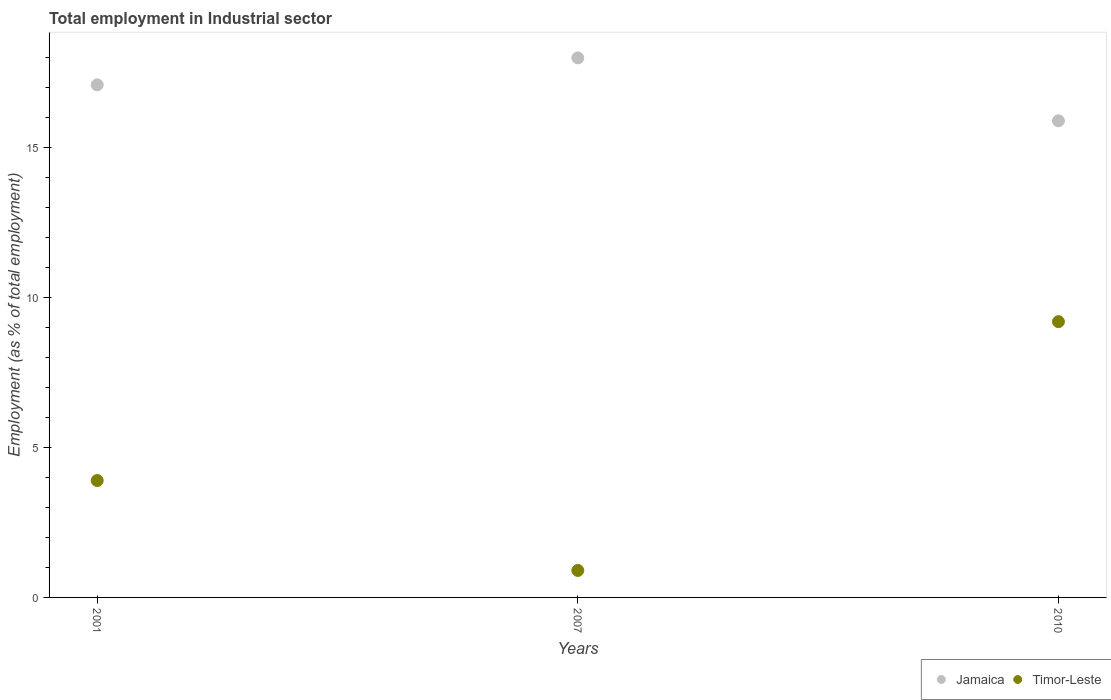What is the employment in industrial sector in Jamaica in 2001?
Your response must be concise. 17.1. Across all years, what is the maximum employment in industrial sector in Timor-Leste?
Give a very brief answer. 9.2. Across all years, what is the minimum employment in industrial sector in Jamaica?
Offer a very short reply. 15.9. In which year was the employment in industrial sector in Jamaica maximum?
Your answer should be compact. 2007. What is the total employment in industrial sector in Timor-Leste in the graph?
Ensure brevity in your answer.  14. What is the difference between the employment in industrial sector in Timor-Leste in 2007 and that in 2010?
Provide a short and direct response. -8.3. What is the difference between the employment in industrial sector in Jamaica in 2007 and the employment in industrial sector in Timor-Leste in 2010?
Offer a terse response. 8.8. In the year 2010, what is the difference between the employment in industrial sector in Jamaica and employment in industrial sector in Timor-Leste?
Give a very brief answer. 6.7. What is the ratio of the employment in industrial sector in Timor-Leste in 2007 to that in 2010?
Your answer should be very brief. 0.1. What is the difference between the highest and the second highest employment in industrial sector in Timor-Leste?
Offer a very short reply. 5.3. What is the difference between the highest and the lowest employment in industrial sector in Jamaica?
Give a very brief answer. 2.1. Does the employment in industrial sector in Timor-Leste monotonically increase over the years?
Ensure brevity in your answer.  No. Is the employment in industrial sector in Timor-Leste strictly less than the employment in industrial sector in Jamaica over the years?
Your response must be concise. Yes. How many years are there in the graph?
Your answer should be very brief. 3. Where does the legend appear in the graph?
Provide a short and direct response. Bottom right. How many legend labels are there?
Give a very brief answer. 2. How are the legend labels stacked?
Offer a very short reply. Horizontal. What is the title of the graph?
Offer a very short reply. Total employment in Industrial sector. Does "Bosnia and Herzegovina" appear as one of the legend labels in the graph?
Give a very brief answer. No. What is the label or title of the Y-axis?
Make the answer very short. Employment (as % of total employment). What is the Employment (as % of total employment) in Jamaica in 2001?
Provide a short and direct response. 17.1. What is the Employment (as % of total employment) in Timor-Leste in 2001?
Provide a succinct answer. 3.9. What is the Employment (as % of total employment) in Jamaica in 2007?
Provide a short and direct response. 18. What is the Employment (as % of total employment) of Timor-Leste in 2007?
Offer a terse response. 0.9. What is the Employment (as % of total employment) in Jamaica in 2010?
Provide a short and direct response. 15.9. What is the Employment (as % of total employment) of Timor-Leste in 2010?
Give a very brief answer. 9.2. Across all years, what is the maximum Employment (as % of total employment) in Timor-Leste?
Your answer should be very brief. 9.2. Across all years, what is the minimum Employment (as % of total employment) of Jamaica?
Your answer should be compact. 15.9. Across all years, what is the minimum Employment (as % of total employment) of Timor-Leste?
Ensure brevity in your answer.  0.9. What is the total Employment (as % of total employment) of Timor-Leste in the graph?
Give a very brief answer. 14. What is the difference between the Employment (as % of total employment) of Jamaica in 2001 and that in 2007?
Offer a terse response. -0.9. What is the difference between the Employment (as % of total employment) in Timor-Leste in 2001 and that in 2007?
Offer a terse response. 3. What is the difference between the Employment (as % of total employment) in Jamaica in 2001 and that in 2010?
Make the answer very short. 1.2. What is the difference between the Employment (as % of total employment) in Timor-Leste in 2001 and that in 2010?
Give a very brief answer. -5.3. What is the difference between the Employment (as % of total employment) in Jamaica in 2007 and that in 2010?
Keep it short and to the point. 2.1. What is the difference between the Employment (as % of total employment) in Jamaica in 2001 and the Employment (as % of total employment) in Timor-Leste in 2007?
Ensure brevity in your answer.  16.2. What is the difference between the Employment (as % of total employment) of Jamaica in 2001 and the Employment (as % of total employment) of Timor-Leste in 2010?
Offer a terse response. 7.9. What is the difference between the Employment (as % of total employment) in Jamaica in 2007 and the Employment (as % of total employment) in Timor-Leste in 2010?
Offer a very short reply. 8.8. What is the average Employment (as % of total employment) in Jamaica per year?
Your response must be concise. 17. What is the average Employment (as % of total employment) in Timor-Leste per year?
Your response must be concise. 4.67. In the year 2001, what is the difference between the Employment (as % of total employment) of Jamaica and Employment (as % of total employment) of Timor-Leste?
Keep it short and to the point. 13.2. What is the ratio of the Employment (as % of total employment) of Jamaica in 2001 to that in 2007?
Make the answer very short. 0.95. What is the ratio of the Employment (as % of total employment) of Timor-Leste in 2001 to that in 2007?
Offer a very short reply. 4.33. What is the ratio of the Employment (as % of total employment) of Jamaica in 2001 to that in 2010?
Provide a short and direct response. 1.08. What is the ratio of the Employment (as % of total employment) of Timor-Leste in 2001 to that in 2010?
Give a very brief answer. 0.42. What is the ratio of the Employment (as % of total employment) in Jamaica in 2007 to that in 2010?
Ensure brevity in your answer.  1.13. What is the ratio of the Employment (as % of total employment) of Timor-Leste in 2007 to that in 2010?
Provide a short and direct response. 0.1. What is the difference between the highest and the second highest Employment (as % of total employment) of Jamaica?
Keep it short and to the point. 0.9. What is the difference between the highest and the second highest Employment (as % of total employment) in Timor-Leste?
Offer a very short reply. 5.3. What is the difference between the highest and the lowest Employment (as % of total employment) in Jamaica?
Your answer should be compact. 2.1. What is the difference between the highest and the lowest Employment (as % of total employment) in Timor-Leste?
Give a very brief answer. 8.3. 